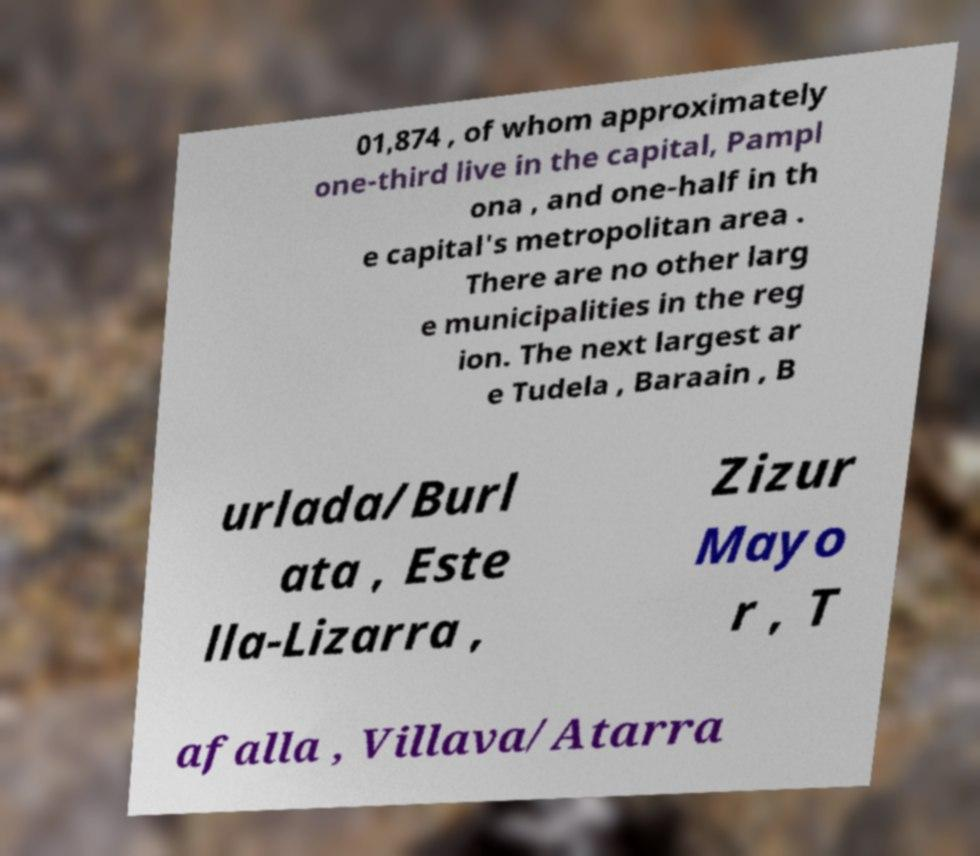I need the written content from this picture converted into text. Can you do that? 01,874 , of whom approximately one-third live in the capital, Pampl ona , and one-half in th e capital's metropolitan area . There are no other larg e municipalities in the reg ion. The next largest ar e Tudela , Baraain , B urlada/Burl ata , Este lla-Lizarra , Zizur Mayo r , T afalla , Villava/Atarra 